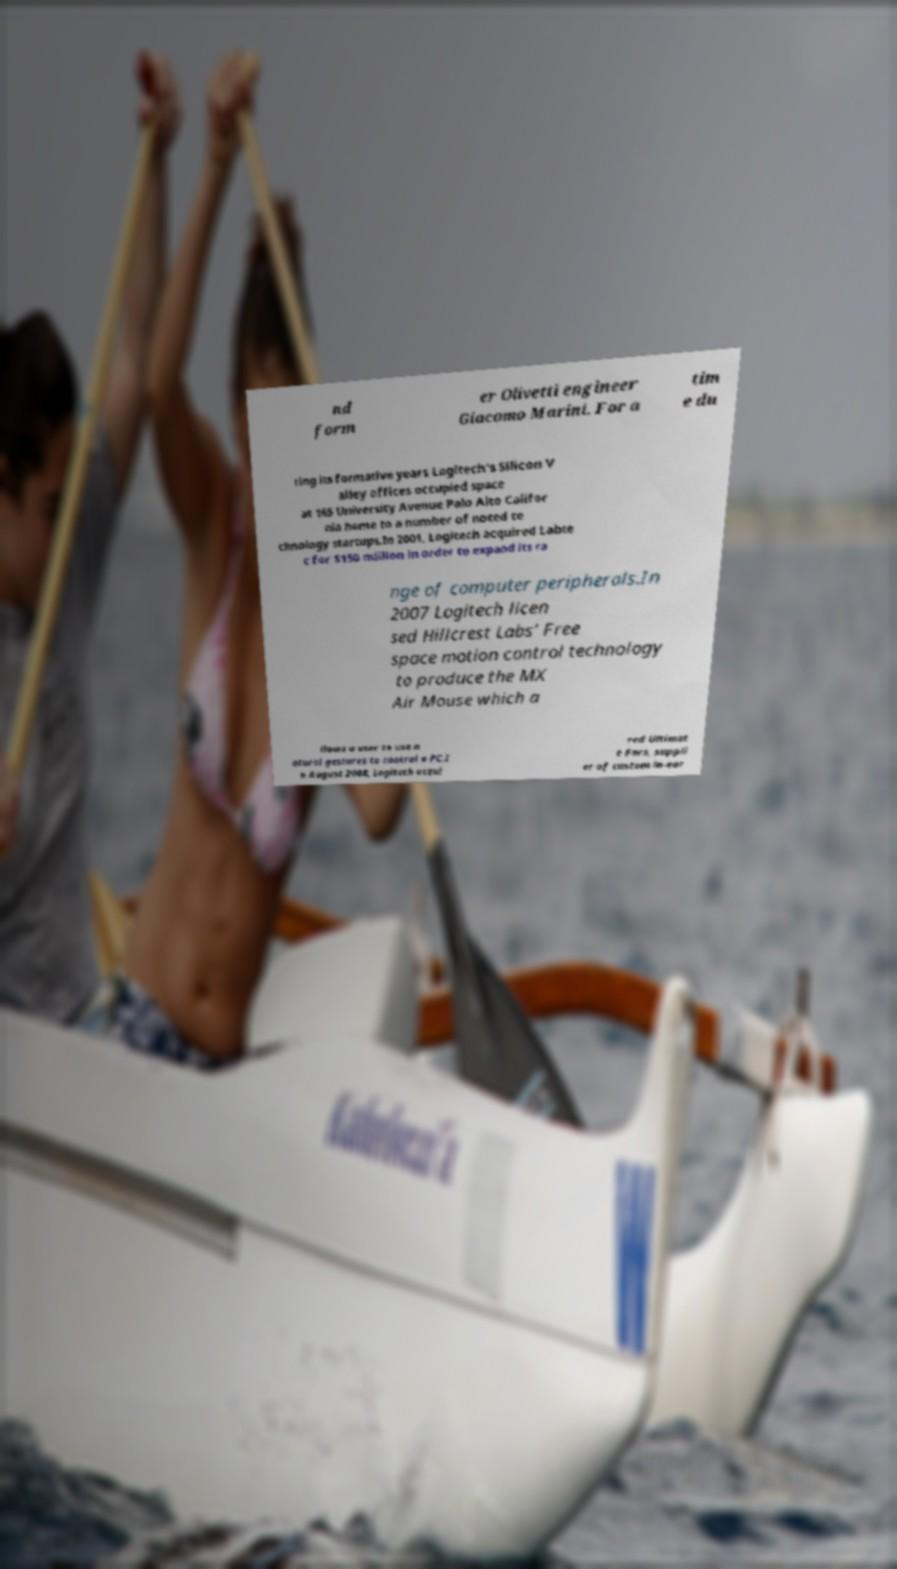Can you read and provide the text displayed in the image?This photo seems to have some interesting text. Can you extract and type it out for me? nd form er Olivetti engineer Giacomo Marini. For a tim e du ring its formative years Logitech's Silicon V alley offices occupied space at 165 University Avenue Palo Alto Califor nia home to a number of noted te chnology startups.In 2001, Logitech acquired Labte c for $150 million in order to expand its ra nge of computer peripherals.In 2007 Logitech licen sed Hillcrest Labs' Free space motion control technology to produce the MX Air Mouse which a llows a user to use n atural gestures to control a PC.I n August 2008, Logitech acqui red Ultimat e Ears, suppli er of custom in-ear 